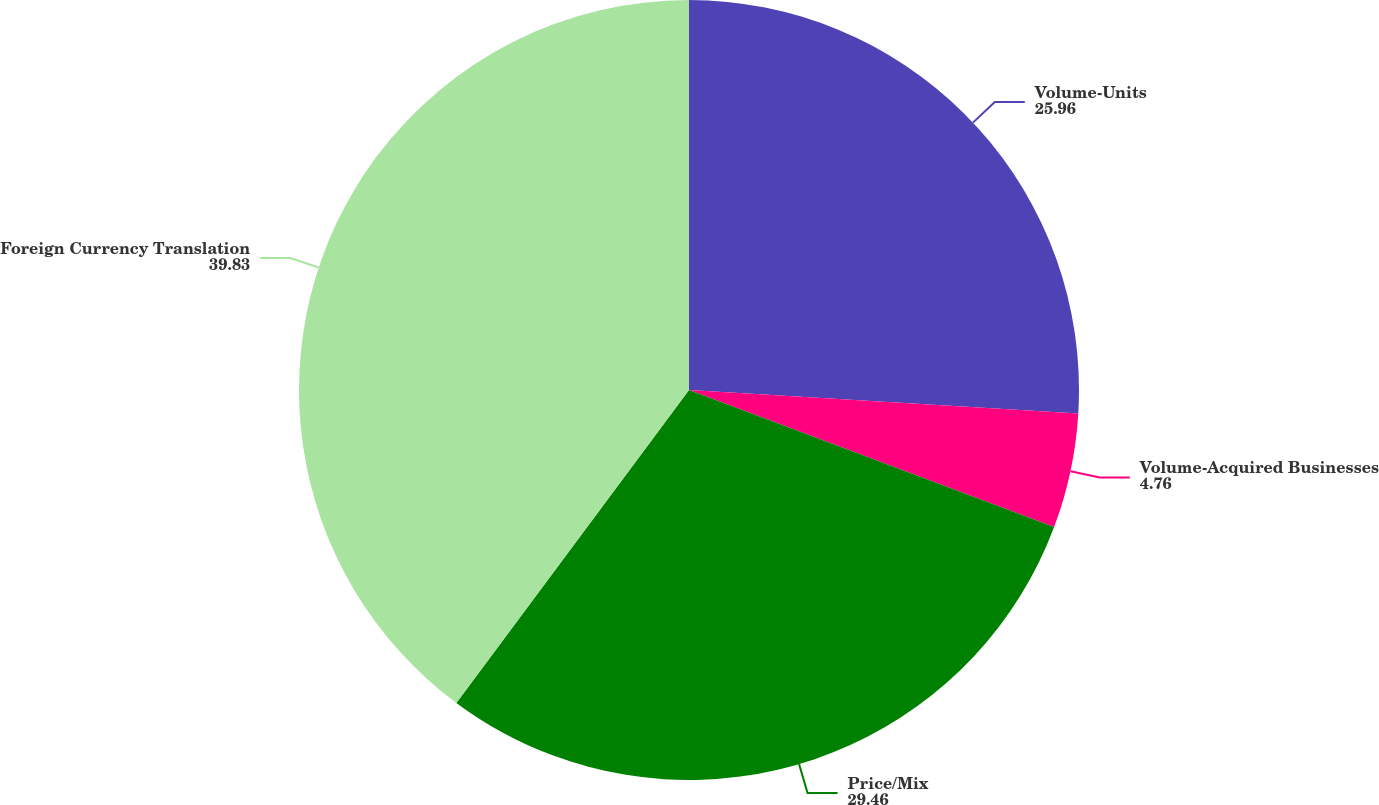Convert chart to OTSL. <chart><loc_0><loc_0><loc_500><loc_500><pie_chart><fcel>Volume-Units<fcel>Volume-Acquired Businesses<fcel>Price/Mix<fcel>Foreign Currency Translation<nl><fcel>25.96%<fcel>4.76%<fcel>29.46%<fcel>39.83%<nl></chart> 